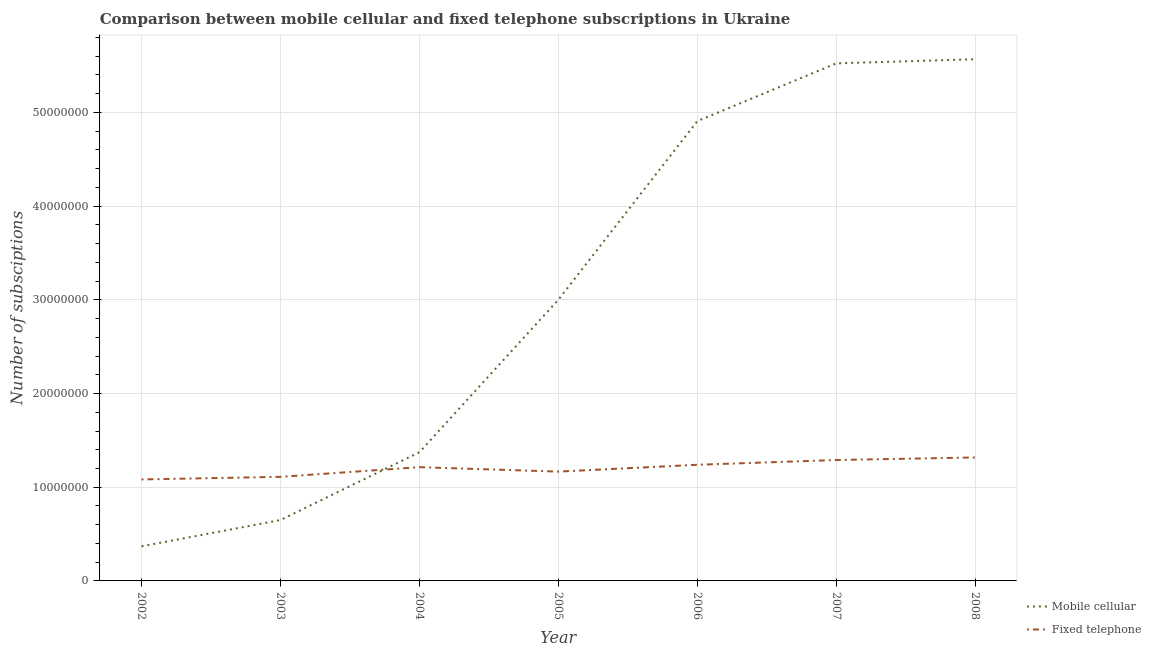How many different coloured lines are there?
Offer a very short reply. 2. Is the number of lines equal to the number of legend labels?
Your answer should be compact. Yes. What is the number of mobile cellular subscriptions in 2005?
Keep it short and to the point. 3.00e+07. Across all years, what is the maximum number of fixed telephone subscriptions?
Your response must be concise. 1.32e+07. Across all years, what is the minimum number of fixed telephone subscriptions?
Your answer should be very brief. 1.08e+07. In which year was the number of mobile cellular subscriptions minimum?
Provide a succinct answer. 2002. What is the total number of mobile cellular subscriptions in the graph?
Provide a short and direct response. 2.14e+08. What is the difference between the number of mobile cellular subscriptions in 2003 and that in 2007?
Your answer should be compact. -4.87e+07. What is the difference between the number of fixed telephone subscriptions in 2006 and the number of mobile cellular subscriptions in 2008?
Make the answer very short. -4.33e+07. What is the average number of mobile cellular subscriptions per year?
Provide a succinct answer. 3.06e+07. In the year 2008, what is the difference between the number of mobile cellular subscriptions and number of fixed telephone subscriptions?
Your response must be concise. 4.25e+07. In how many years, is the number of mobile cellular subscriptions greater than 34000000?
Provide a short and direct response. 3. What is the ratio of the number of mobile cellular subscriptions in 2002 to that in 2007?
Offer a terse response. 0.07. Is the number of fixed telephone subscriptions in 2003 less than that in 2004?
Your response must be concise. Yes. Is the difference between the number of fixed telephone subscriptions in 2002 and 2008 greater than the difference between the number of mobile cellular subscriptions in 2002 and 2008?
Keep it short and to the point. Yes. What is the difference between the highest and the second highest number of fixed telephone subscriptions?
Provide a succinct answer. 2.71e+05. What is the difference between the highest and the lowest number of fixed telephone subscriptions?
Offer a very short reply. 2.34e+06. Does the number of mobile cellular subscriptions monotonically increase over the years?
Offer a very short reply. Yes. How many lines are there?
Keep it short and to the point. 2. How many years are there in the graph?
Your answer should be very brief. 7. What is the difference between two consecutive major ticks on the Y-axis?
Your answer should be very brief. 1.00e+07. Does the graph contain grids?
Provide a short and direct response. Yes. Where does the legend appear in the graph?
Provide a short and direct response. Bottom right. How many legend labels are there?
Offer a terse response. 2. What is the title of the graph?
Offer a terse response. Comparison between mobile cellular and fixed telephone subscriptions in Ukraine. What is the label or title of the X-axis?
Ensure brevity in your answer.  Year. What is the label or title of the Y-axis?
Give a very brief answer. Number of subsciptions. What is the Number of subsciptions of Mobile cellular in 2002?
Provide a short and direct response. 3.69e+06. What is the Number of subsciptions of Fixed telephone in 2002?
Your answer should be compact. 1.08e+07. What is the Number of subsciptions of Mobile cellular in 2003?
Keep it short and to the point. 6.50e+06. What is the Number of subsciptions in Fixed telephone in 2003?
Your answer should be compact. 1.11e+07. What is the Number of subsciptions in Mobile cellular in 2004?
Your answer should be very brief. 1.37e+07. What is the Number of subsciptions in Fixed telephone in 2004?
Offer a terse response. 1.21e+07. What is the Number of subsciptions of Mobile cellular in 2005?
Provide a succinct answer. 3.00e+07. What is the Number of subsciptions of Fixed telephone in 2005?
Provide a succinct answer. 1.17e+07. What is the Number of subsciptions in Mobile cellular in 2006?
Your answer should be compact. 4.91e+07. What is the Number of subsciptions of Fixed telephone in 2006?
Offer a very short reply. 1.24e+07. What is the Number of subsciptions of Mobile cellular in 2007?
Provide a short and direct response. 5.52e+07. What is the Number of subsciptions of Fixed telephone in 2007?
Give a very brief answer. 1.29e+07. What is the Number of subsciptions in Mobile cellular in 2008?
Your answer should be compact. 5.57e+07. What is the Number of subsciptions in Fixed telephone in 2008?
Make the answer very short. 1.32e+07. Across all years, what is the maximum Number of subsciptions in Mobile cellular?
Make the answer very short. 5.57e+07. Across all years, what is the maximum Number of subsciptions in Fixed telephone?
Give a very brief answer. 1.32e+07. Across all years, what is the minimum Number of subsciptions of Mobile cellular?
Make the answer very short. 3.69e+06. Across all years, what is the minimum Number of subsciptions of Fixed telephone?
Keep it short and to the point. 1.08e+07. What is the total Number of subsciptions of Mobile cellular in the graph?
Provide a short and direct response. 2.14e+08. What is the total Number of subsciptions in Fixed telephone in the graph?
Provide a short and direct response. 8.42e+07. What is the difference between the Number of subsciptions in Mobile cellular in 2002 and that in 2003?
Your answer should be very brief. -2.81e+06. What is the difference between the Number of subsciptions in Fixed telephone in 2002 and that in 2003?
Make the answer very short. -2.76e+05. What is the difference between the Number of subsciptions of Mobile cellular in 2002 and that in 2004?
Provide a succinct answer. -1.00e+07. What is the difference between the Number of subsciptions in Fixed telephone in 2002 and that in 2004?
Ensure brevity in your answer.  -1.31e+06. What is the difference between the Number of subsciptions of Mobile cellular in 2002 and that in 2005?
Your answer should be compact. -2.63e+07. What is the difference between the Number of subsciptions of Fixed telephone in 2002 and that in 2005?
Provide a succinct answer. -8.33e+05. What is the difference between the Number of subsciptions of Mobile cellular in 2002 and that in 2006?
Give a very brief answer. -4.54e+07. What is the difference between the Number of subsciptions in Fixed telephone in 2002 and that in 2006?
Ensure brevity in your answer.  -1.56e+06. What is the difference between the Number of subsciptions of Mobile cellular in 2002 and that in 2007?
Your answer should be very brief. -5.15e+07. What is the difference between the Number of subsciptions of Fixed telephone in 2002 and that in 2007?
Your response must be concise. -2.07e+06. What is the difference between the Number of subsciptions of Mobile cellular in 2002 and that in 2008?
Your answer should be compact. -5.20e+07. What is the difference between the Number of subsciptions of Fixed telephone in 2002 and that in 2008?
Keep it short and to the point. -2.34e+06. What is the difference between the Number of subsciptions in Mobile cellular in 2003 and that in 2004?
Your answer should be compact. -7.24e+06. What is the difference between the Number of subsciptions of Fixed telephone in 2003 and that in 2004?
Ensure brevity in your answer.  -1.03e+06. What is the difference between the Number of subsciptions in Mobile cellular in 2003 and that in 2005?
Ensure brevity in your answer.  -2.35e+07. What is the difference between the Number of subsciptions in Fixed telephone in 2003 and that in 2005?
Offer a terse response. -5.57e+05. What is the difference between the Number of subsciptions of Mobile cellular in 2003 and that in 2006?
Provide a succinct answer. -4.26e+07. What is the difference between the Number of subsciptions in Fixed telephone in 2003 and that in 2006?
Provide a short and direct response. -1.29e+06. What is the difference between the Number of subsciptions in Mobile cellular in 2003 and that in 2007?
Offer a terse response. -4.87e+07. What is the difference between the Number of subsciptions in Fixed telephone in 2003 and that in 2007?
Offer a very short reply. -1.80e+06. What is the difference between the Number of subsciptions in Mobile cellular in 2003 and that in 2008?
Ensure brevity in your answer.  -4.92e+07. What is the difference between the Number of subsciptions in Fixed telephone in 2003 and that in 2008?
Keep it short and to the point. -2.07e+06. What is the difference between the Number of subsciptions of Mobile cellular in 2004 and that in 2005?
Your answer should be very brief. -1.63e+07. What is the difference between the Number of subsciptions in Fixed telephone in 2004 and that in 2005?
Keep it short and to the point. 4.75e+05. What is the difference between the Number of subsciptions of Mobile cellular in 2004 and that in 2006?
Your answer should be compact. -3.53e+07. What is the difference between the Number of subsciptions of Fixed telephone in 2004 and that in 2006?
Provide a short and direct response. -2.55e+05. What is the difference between the Number of subsciptions in Mobile cellular in 2004 and that in 2007?
Keep it short and to the point. -4.15e+07. What is the difference between the Number of subsciptions of Fixed telephone in 2004 and that in 2007?
Give a very brief answer. -7.64e+05. What is the difference between the Number of subsciptions of Mobile cellular in 2004 and that in 2008?
Your response must be concise. -4.19e+07. What is the difference between the Number of subsciptions in Fixed telephone in 2004 and that in 2008?
Make the answer very short. -1.03e+06. What is the difference between the Number of subsciptions in Mobile cellular in 2005 and that in 2006?
Offer a terse response. -1.91e+07. What is the difference between the Number of subsciptions in Fixed telephone in 2005 and that in 2006?
Make the answer very short. -7.31e+05. What is the difference between the Number of subsciptions of Mobile cellular in 2005 and that in 2007?
Give a very brief answer. -2.52e+07. What is the difference between the Number of subsciptions in Fixed telephone in 2005 and that in 2007?
Keep it short and to the point. -1.24e+06. What is the difference between the Number of subsciptions in Mobile cellular in 2005 and that in 2008?
Your response must be concise. -2.57e+07. What is the difference between the Number of subsciptions of Fixed telephone in 2005 and that in 2008?
Provide a short and direct response. -1.51e+06. What is the difference between the Number of subsciptions in Mobile cellular in 2006 and that in 2007?
Give a very brief answer. -6.16e+06. What is the difference between the Number of subsciptions in Fixed telephone in 2006 and that in 2007?
Provide a succinct answer. -5.09e+05. What is the difference between the Number of subsciptions of Mobile cellular in 2006 and that in 2008?
Offer a very short reply. -6.61e+06. What is the difference between the Number of subsciptions of Fixed telephone in 2006 and that in 2008?
Your answer should be very brief. -7.80e+05. What is the difference between the Number of subsciptions of Mobile cellular in 2007 and that in 2008?
Keep it short and to the point. -4.41e+05. What is the difference between the Number of subsciptions in Fixed telephone in 2007 and that in 2008?
Offer a very short reply. -2.71e+05. What is the difference between the Number of subsciptions in Mobile cellular in 2002 and the Number of subsciptions in Fixed telephone in 2003?
Offer a very short reply. -7.42e+06. What is the difference between the Number of subsciptions in Mobile cellular in 2002 and the Number of subsciptions in Fixed telephone in 2004?
Your answer should be compact. -8.45e+06. What is the difference between the Number of subsciptions in Mobile cellular in 2002 and the Number of subsciptions in Fixed telephone in 2005?
Provide a succinct answer. -7.97e+06. What is the difference between the Number of subsciptions of Mobile cellular in 2002 and the Number of subsciptions of Fixed telephone in 2006?
Make the answer very short. -8.70e+06. What is the difference between the Number of subsciptions of Mobile cellular in 2002 and the Number of subsciptions of Fixed telephone in 2007?
Provide a short and direct response. -9.21e+06. What is the difference between the Number of subsciptions of Mobile cellular in 2002 and the Number of subsciptions of Fixed telephone in 2008?
Your answer should be compact. -9.48e+06. What is the difference between the Number of subsciptions in Mobile cellular in 2003 and the Number of subsciptions in Fixed telephone in 2004?
Make the answer very short. -5.64e+06. What is the difference between the Number of subsciptions in Mobile cellular in 2003 and the Number of subsciptions in Fixed telephone in 2005?
Keep it short and to the point. -5.17e+06. What is the difference between the Number of subsciptions in Mobile cellular in 2003 and the Number of subsciptions in Fixed telephone in 2006?
Give a very brief answer. -5.90e+06. What is the difference between the Number of subsciptions of Mobile cellular in 2003 and the Number of subsciptions of Fixed telephone in 2007?
Offer a terse response. -6.41e+06. What is the difference between the Number of subsciptions of Mobile cellular in 2003 and the Number of subsciptions of Fixed telephone in 2008?
Your answer should be very brief. -6.68e+06. What is the difference between the Number of subsciptions of Mobile cellular in 2004 and the Number of subsciptions of Fixed telephone in 2005?
Keep it short and to the point. 2.07e+06. What is the difference between the Number of subsciptions of Mobile cellular in 2004 and the Number of subsciptions of Fixed telephone in 2006?
Offer a terse response. 1.34e+06. What is the difference between the Number of subsciptions of Mobile cellular in 2004 and the Number of subsciptions of Fixed telephone in 2007?
Your response must be concise. 8.29e+05. What is the difference between the Number of subsciptions in Mobile cellular in 2004 and the Number of subsciptions in Fixed telephone in 2008?
Offer a very short reply. 5.58e+05. What is the difference between the Number of subsciptions of Mobile cellular in 2005 and the Number of subsciptions of Fixed telephone in 2006?
Provide a short and direct response. 1.76e+07. What is the difference between the Number of subsciptions in Mobile cellular in 2005 and the Number of subsciptions in Fixed telephone in 2007?
Give a very brief answer. 1.71e+07. What is the difference between the Number of subsciptions of Mobile cellular in 2005 and the Number of subsciptions of Fixed telephone in 2008?
Keep it short and to the point. 1.68e+07. What is the difference between the Number of subsciptions of Mobile cellular in 2006 and the Number of subsciptions of Fixed telephone in 2007?
Ensure brevity in your answer.  3.62e+07. What is the difference between the Number of subsciptions of Mobile cellular in 2006 and the Number of subsciptions of Fixed telephone in 2008?
Offer a very short reply. 3.59e+07. What is the difference between the Number of subsciptions in Mobile cellular in 2007 and the Number of subsciptions in Fixed telephone in 2008?
Offer a very short reply. 4.21e+07. What is the average Number of subsciptions in Mobile cellular per year?
Give a very brief answer. 3.06e+07. What is the average Number of subsciptions in Fixed telephone per year?
Provide a short and direct response. 1.20e+07. In the year 2002, what is the difference between the Number of subsciptions in Mobile cellular and Number of subsciptions in Fixed telephone?
Offer a terse response. -7.14e+06. In the year 2003, what is the difference between the Number of subsciptions in Mobile cellular and Number of subsciptions in Fixed telephone?
Your response must be concise. -4.61e+06. In the year 2004, what is the difference between the Number of subsciptions of Mobile cellular and Number of subsciptions of Fixed telephone?
Offer a terse response. 1.59e+06. In the year 2005, what is the difference between the Number of subsciptions in Mobile cellular and Number of subsciptions in Fixed telephone?
Your answer should be compact. 1.83e+07. In the year 2006, what is the difference between the Number of subsciptions of Mobile cellular and Number of subsciptions of Fixed telephone?
Offer a terse response. 3.67e+07. In the year 2007, what is the difference between the Number of subsciptions in Mobile cellular and Number of subsciptions in Fixed telephone?
Keep it short and to the point. 4.23e+07. In the year 2008, what is the difference between the Number of subsciptions of Mobile cellular and Number of subsciptions of Fixed telephone?
Provide a succinct answer. 4.25e+07. What is the ratio of the Number of subsciptions of Mobile cellular in 2002 to that in 2003?
Give a very brief answer. 0.57. What is the ratio of the Number of subsciptions of Fixed telephone in 2002 to that in 2003?
Provide a succinct answer. 0.98. What is the ratio of the Number of subsciptions of Mobile cellular in 2002 to that in 2004?
Your response must be concise. 0.27. What is the ratio of the Number of subsciptions of Fixed telephone in 2002 to that in 2004?
Keep it short and to the point. 0.89. What is the ratio of the Number of subsciptions in Mobile cellular in 2002 to that in 2005?
Your response must be concise. 0.12. What is the ratio of the Number of subsciptions in Fixed telephone in 2002 to that in 2005?
Your response must be concise. 0.93. What is the ratio of the Number of subsciptions in Mobile cellular in 2002 to that in 2006?
Provide a succinct answer. 0.08. What is the ratio of the Number of subsciptions in Fixed telephone in 2002 to that in 2006?
Ensure brevity in your answer.  0.87. What is the ratio of the Number of subsciptions in Mobile cellular in 2002 to that in 2007?
Your response must be concise. 0.07. What is the ratio of the Number of subsciptions of Fixed telephone in 2002 to that in 2007?
Provide a succinct answer. 0.84. What is the ratio of the Number of subsciptions of Mobile cellular in 2002 to that in 2008?
Offer a terse response. 0.07. What is the ratio of the Number of subsciptions in Fixed telephone in 2002 to that in 2008?
Provide a succinct answer. 0.82. What is the ratio of the Number of subsciptions of Mobile cellular in 2003 to that in 2004?
Provide a succinct answer. 0.47. What is the ratio of the Number of subsciptions in Fixed telephone in 2003 to that in 2004?
Provide a succinct answer. 0.92. What is the ratio of the Number of subsciptions in Mobile cellular in 2003 to that in 2005?
Make the answer very short. 0.22. What is the ratio of the Number of subsciptions of Fixed telephone in 2003 to that in 2005?
Offer a very short reply. 0.95. What is the ratio of the Number of subsciptions in Mobile cellular in 2003 to that in 2006?
Ensure brevity in your answer.  0.13. What is the ratio of the Number of subsciptions in Fixed telephone in 2003 to that in 2006?
Ensure brevity in your answer.  0.9. What is the ratio of the Number of subsciptions in Mobile cellular in 2003 to that in 2007?
Give a very brief answer. 0.12. What is the ratio of the Number of subsciptions in Fixed telephone in 2003 to that in 2007?
Make the answer very short. 0.86. What is the ratio of the Number of subsciptions of Mobile cellular in 2003 to that in 2008?
Offer a terse response. 0.12. What is the ratio of the Number of subsciptions of Fixed telephone in 2003 to that in 2008?
Ensure brevity in your answer.  0.84. What is the ratio of the Number of subsciptions in Mobile cellular in 2004 to that in 2005?
Ensure brevity in your answer.  0.46. What is the ratio of the Number of subsciptions of Fixed telephone in 2004 to that in 2005?
Offer a very short reply. 1.04. What is the ratio of the Number of subsciptions in Mobile cellular in 2004 to that in 2006?
Offer a very short reply. 0.28. What is the ratio of the Number of subsciptions in Fixed telephone in 2004 to that in 2006?
Your response must be concise. 0.98. What is the ratio of the Number of subsciptions of Mobile cellular in 2004 to that in 2007?
Provide a succinct answer. 0.25. What is the ratio of the Number of subsciptions of Fixed telephone in 2004 to that in 2007?
Provide a short and direct response. 0.94. What is the ratio of the Number of subsciptions of Mobile cellular in 2004 to that in 2008?
Your answer should be compact. 0.25. What is the ratio of the Number of subsciptions of Fixed telephone in 2004 to that in 2008?
Provide a succinct answer. 0.92. What is the ratio of the Number of subsciptions in Mobile cellular in 2005 to that in 2006?
Your response must be concise. 0.61. What is the ratio of the Number of subsciptions in Fixed telephone in 2005 to that in 2006?
Provide a succinct answer. 0.94. What is the ratio of the Number of subsciptions of Mobile cellular in 2005 to that in 2007?
Offer a very short reply. 0.54. What is the ratio of the Number of subsciptions of Fixed telephone in 2005 to that in 2007?
Provide a succinct answer. 0.9. What is the ratio of the Number of subsciptions of Mobile cellular in 2005 to that in 2008?
Give a very brief answer. 0.54. What is the ratio of the Number of subsciptions of Fixed telephone in 2005 to that in 2008?
Offer a terse response. 0.89. What is the ratio of the Number of subsciptions of Mobile cellular in 2006 to that in 2007?
Your response must be concise. 0.89. What is the ratio of the Number of subsciptions in Fixed telephone in 2006 to that in 2007?
Offer a terse response. 0.96. What is the ratio of the Number of subsciptions in Mobile cellular in 2006 to that in 2008?
Offer a very short reply. 0.88. What is the ratio of the Number of subsciptions in Fixed telephone in 2006 to that in 2008?
Make the answer very short. 0.94. What is the ratio of the Number of subsciptions of Mobile cellular in 2007 to that in 2008?
Provide a short and direct response. 0.99. What is the ratio of the Number of subsciptions in Fixed telephone in 2007 to that in 2008?
Offer a very short reply. 0.98. What is the difference between the highest and the second highest Number of subsciptions of Mobile cellular?
Give a very brief answer. 4.41e+05. What is the difference between the highest and the second highest Number of subsciptions in Fixed telephone?
Provide a succinct answer. 2.71e+05. What is the difference between the highest and the lowest Number of subsciptions of Mobile cellular?
Offer a very short reply. 5.20e+07. What is the difference between the highest and the lowest Number of subsciptions in Fixed telephone?
Your answer should be very brief. 2.34e+06. 